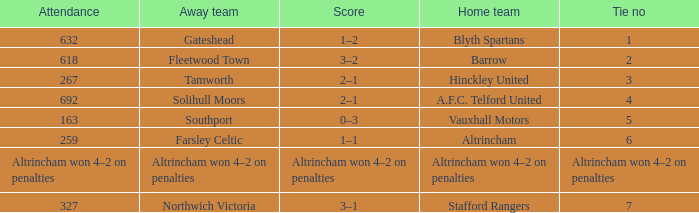Which away team that had a tie of 7? Northwich Victoria. 